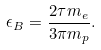<formula> <loc_0><loc_0><loc_500><loc_500>\epsilon _ { B } = \frac { 2 \tau m _ { e } } { 3 \pi m _ { p } } .</formula> 